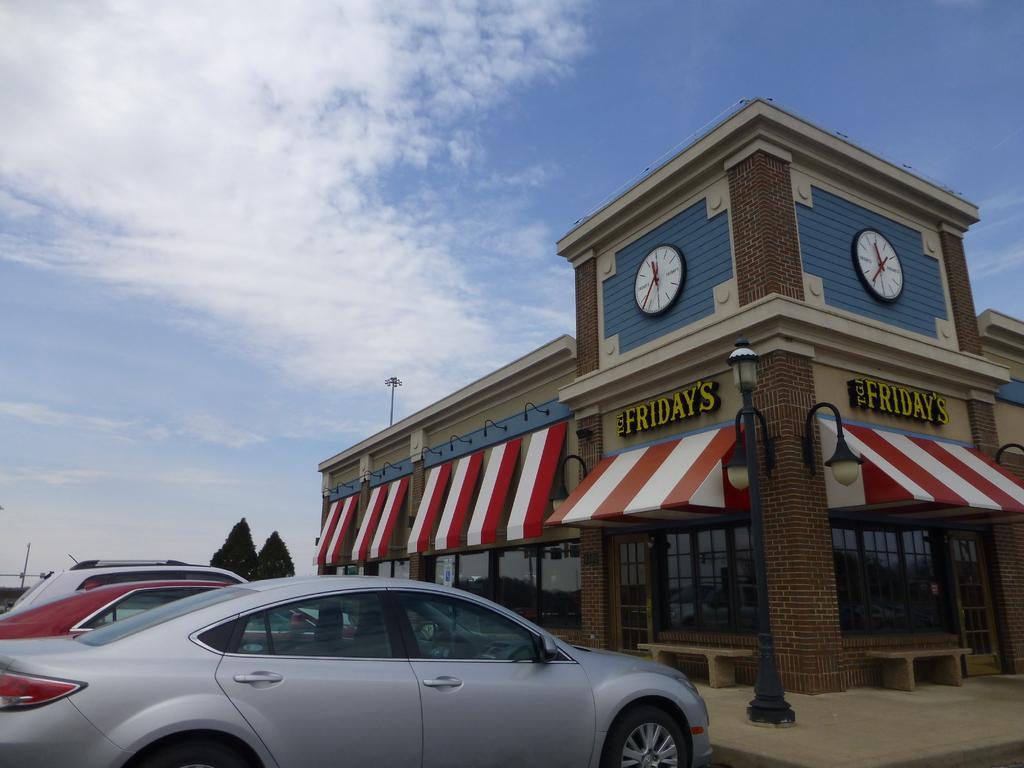Could you give a brief overview of what you see in this image? This looks like a building with the glass doors and a name board attached to it. These are the wall clocks. I can see the cars, which are parked. I think these are the trees. This looks like a light pole. I can see the lamps attached to the wall. These are the benches. I can see the clouds in the sky. 